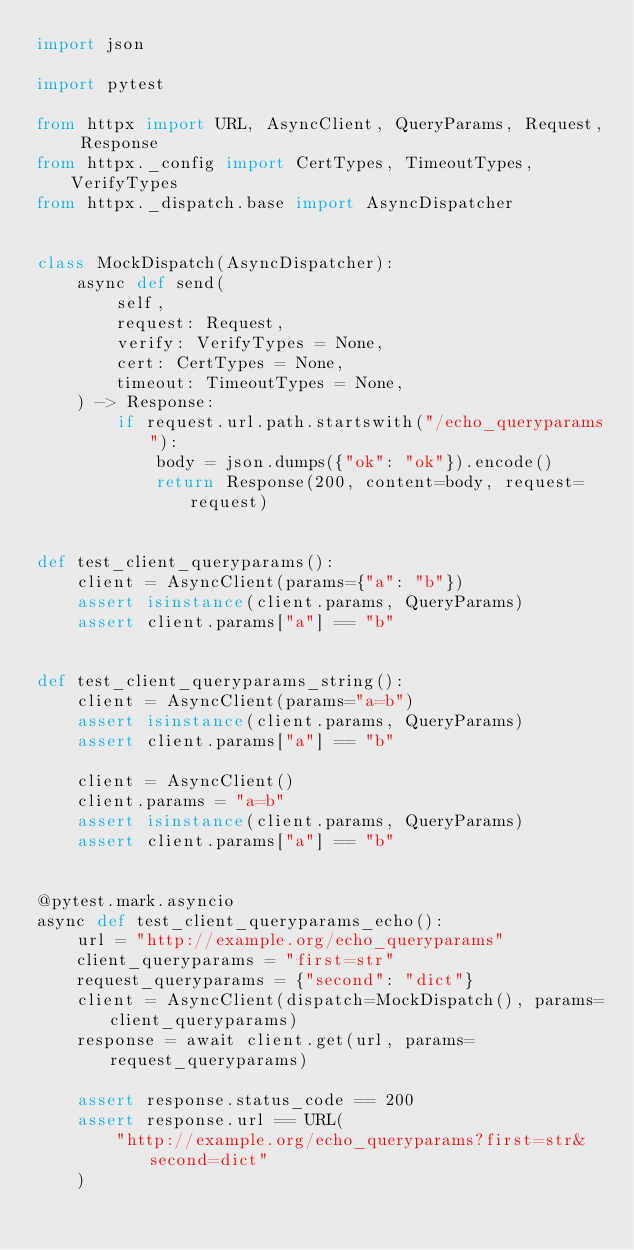<code> <loc_0><loc_0><loc_500><loc_500><_Python_>import json

import pytest

from httpx import URL, AsyncClient, QueryParams, Request, Response
from httpx._config import CertTypes, TimeoutTypes, VerifyTypes
from httpx._dispatch.base import AsyncDispatcher


class MockDispatch(AsyncDispatcher):
    async def send(
        self,
        request: Request,
        verify: VerifyTypes = None,
        cert: CertTypes = None,
        timeout: TimeoutTypes = None,
    ) -> Response:
        if request.url.path.startswith("/echo_queryparams"):
            body = json.dumps({"ok": "ok"}).encode()
            return Response(200, content=body, request=request)


def test_client_queryparams():
    client = AsyncClient(params={"a": "b"})
    assert isinstance(client.params, QueryParams)
    assert client.params["a"] == "b"


def test_client_queryparams_string():
    client = AsyncClient(params="a=b")
    assert isinstance(client.params, QueryParams)
    assert client.params["a"] == "b"

    client = AsyncClient()
    client.params = "a=b"
    assert isinstance(client.params, QueryParams)
    assert client.params["a"] == "b"


@pytest.mark.asyncio
async def test_client_queryparams_echo():
    url = "http://example.org/echo_queryparams"
    client_queryparams = "first=str"
    request_queryparams = {"second": "dict"}
    client = AsyncClient(dispatch=MockDispatch(), params=client_queryparams)
    response = await client.get(url, params=request_queryparams)

    assert response.status_code == 200
    assert response.url == URL(
        "http://example.org/echo_queryparams?first=str&second=dict"
    )
</code> 